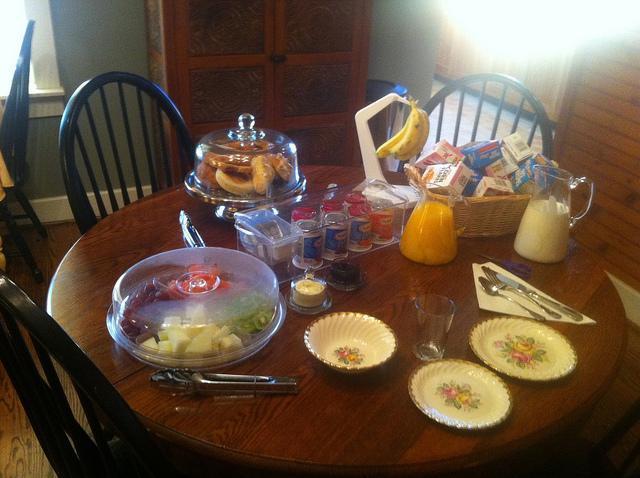What are the plastic lids used for when covering these trays of food?
Choose the correct response, then elucidate: 'Answer: answer
Rationale: rationale.'
Options: Transport, heat, cold, protection. Answer: protection.
Rationale: Food is covered with lids. lids are used to protect food. 